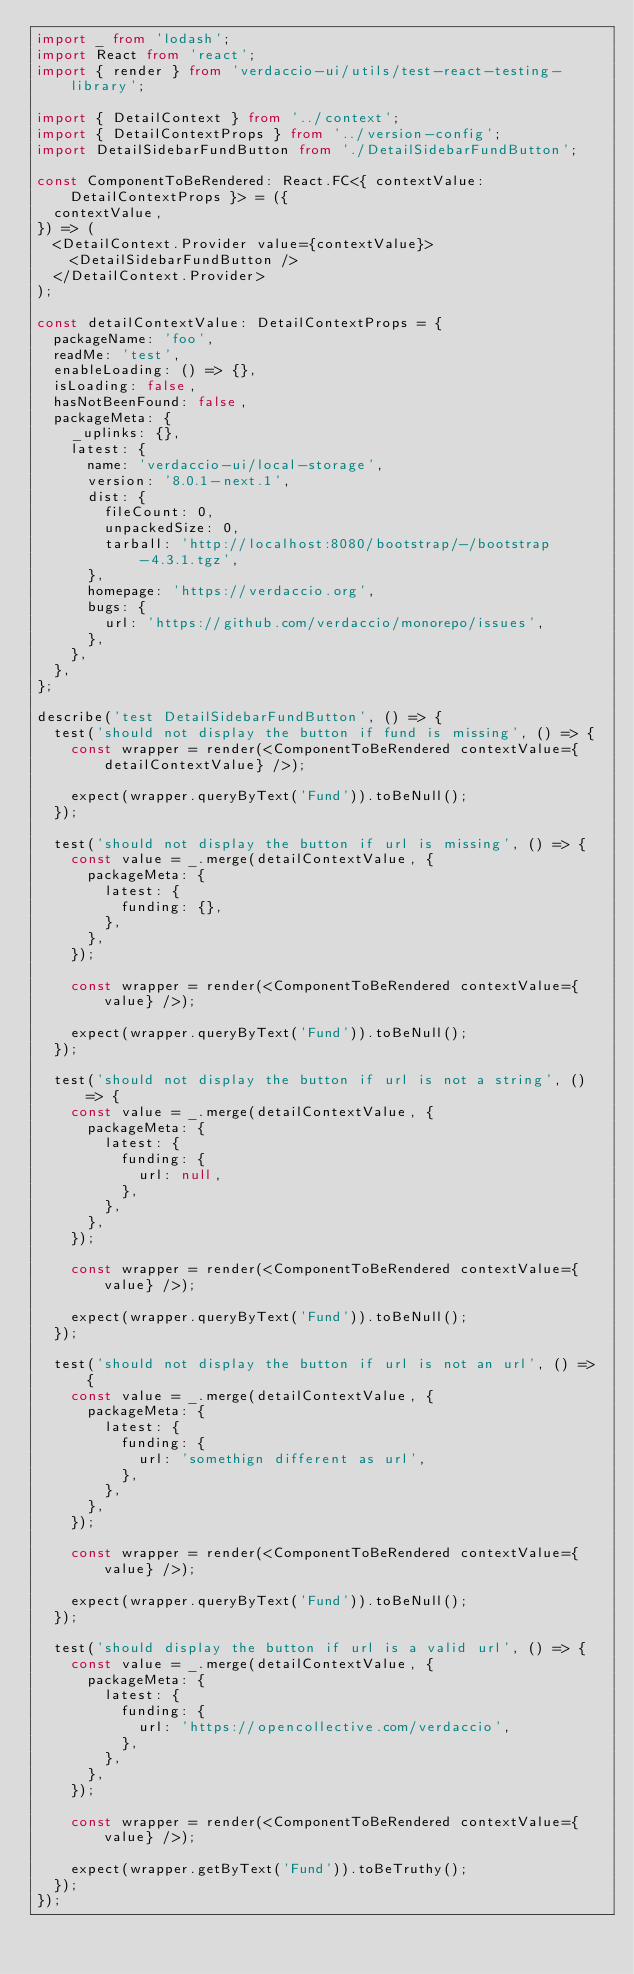<code> <loc_0><loc_0><loc_500><loc_500><_TypeScript_>import _ from 'lodash';
import React from 'react';
import { render } from 'verdaccio-ui/utils/test-react-testing-library';

import { DetailContext } from '../context';
import { DetailContextProps } from '../version-config';
import DetailSidebarFundButton from './DetailSidebarFundButton';

const ComponentToBeRendered: React.FC<{ contextValue: DetailContextProps }> = ({
  contextValue,
}) => (
  <DetailContext.Provider value={contextValue}>
    <DetailSidebarFundButton />
  </DetailContext.Provider>
);

const detailContextValue: DetailContextProps = {
  packageName: 'foo',
  readMe: 'test',
  enableLoading: () => {},
  isLoading: false,
  hasNotBeenFound: false,
  packageMeta: {
    _uplinks: {},
    latest: {
      name: 'verdaccio-ui/local-storage',
      version: '8.0.1-next.1',
      dist: {
        fileCount: 0,
        unpackedSize: 0,
        tarball: 'http://localhost:8080/bootstrap/-/bootstrap-4.3.1.tgz',
      },
      homepage: 'https://verdaccio.org',
      bugs: {
        url: 'https://github.com/verdaccio/monorepo/issues',
      },
    },
  },
};

describe('test DetailSidebarFundButton', () => {
  test('should not display the button if fund is missing', () => {
    const wrapper = render(<ComponentToBeRendered contextValue={detailContextValue} />);

    expect(wrapper.queryByText('Fund')).toBeNull();
  });

  test('should not display the button if url is missing', () => {
    const value = _.merge(detailContextValue, {
      packageMeta: {
        latest: {
          funding: {},
        },
      },
    });

    const wrapper = render(<ComponentToBeRendered contextValue={value} />);

    expect(wrapper.queryByText('Fund')).toBeNull();
  });

  test('should not display the button if url is not a string', () => {
    const value = _.merge(detailContextValue, {
      packageMeta: {
        latest: {
          funding: {
            url: null,
          },
        },
      },
    });

    const wrapper = render(<ComponentToBeRendered contextValue={value} />);

    expect(wrapper.queryByText('Fund')).toBeNull();
  });

  test('should not display the button if url is not an url', () => {
    const value = _.merge(detailContextValue, {
      packageMeta: {
        latest: {
          funding: {
            url: 'somethign different as url',
          },
        },
      },
    });

    const wrapper = render(<ComponentToBeRendered contextValue={value} />);

    expect(wrapper.queryByText('Fund')).toBeNull();
  });

  test('should display the button if url is a valid url', () => {
    const value = _.merge(detailContextValue, {
      packageMeta: {
        latest: {
          funding: {
            url: 'https://opencollective.com/verdaccio',
          },
        },
      },
    });

    const wrapper = render(<ComponentToBeRendered contextValue={value} />);

    expect(wrapper.getByText('Fund')).toBeTruthy();
  });
});
</code> 